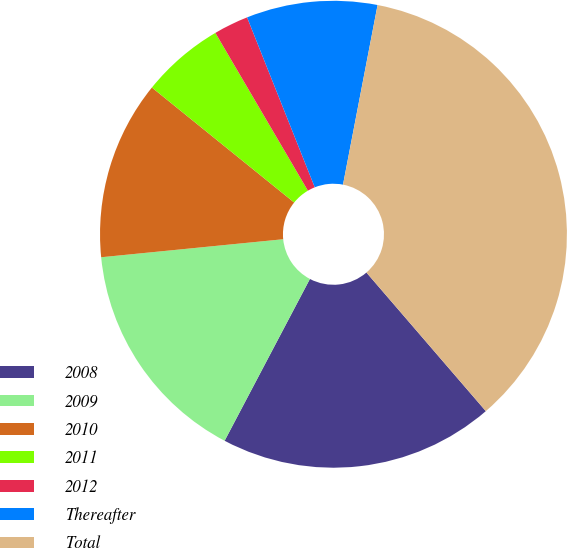<chart> <loc_0><loc_0><loc_500><loc_500><pie_chart><fcel>2008<fcel>2009<fcel>2010<fcel>2011<fcel>2012<fcel>Thereafter<fcel>Total<nl><fcel>19.04%<fcel>15.71%<fcel>12.39%<fcel>5.74%<fcel>2.41%<fcel>9.06%<fcel>35.66%<nl></chart> 